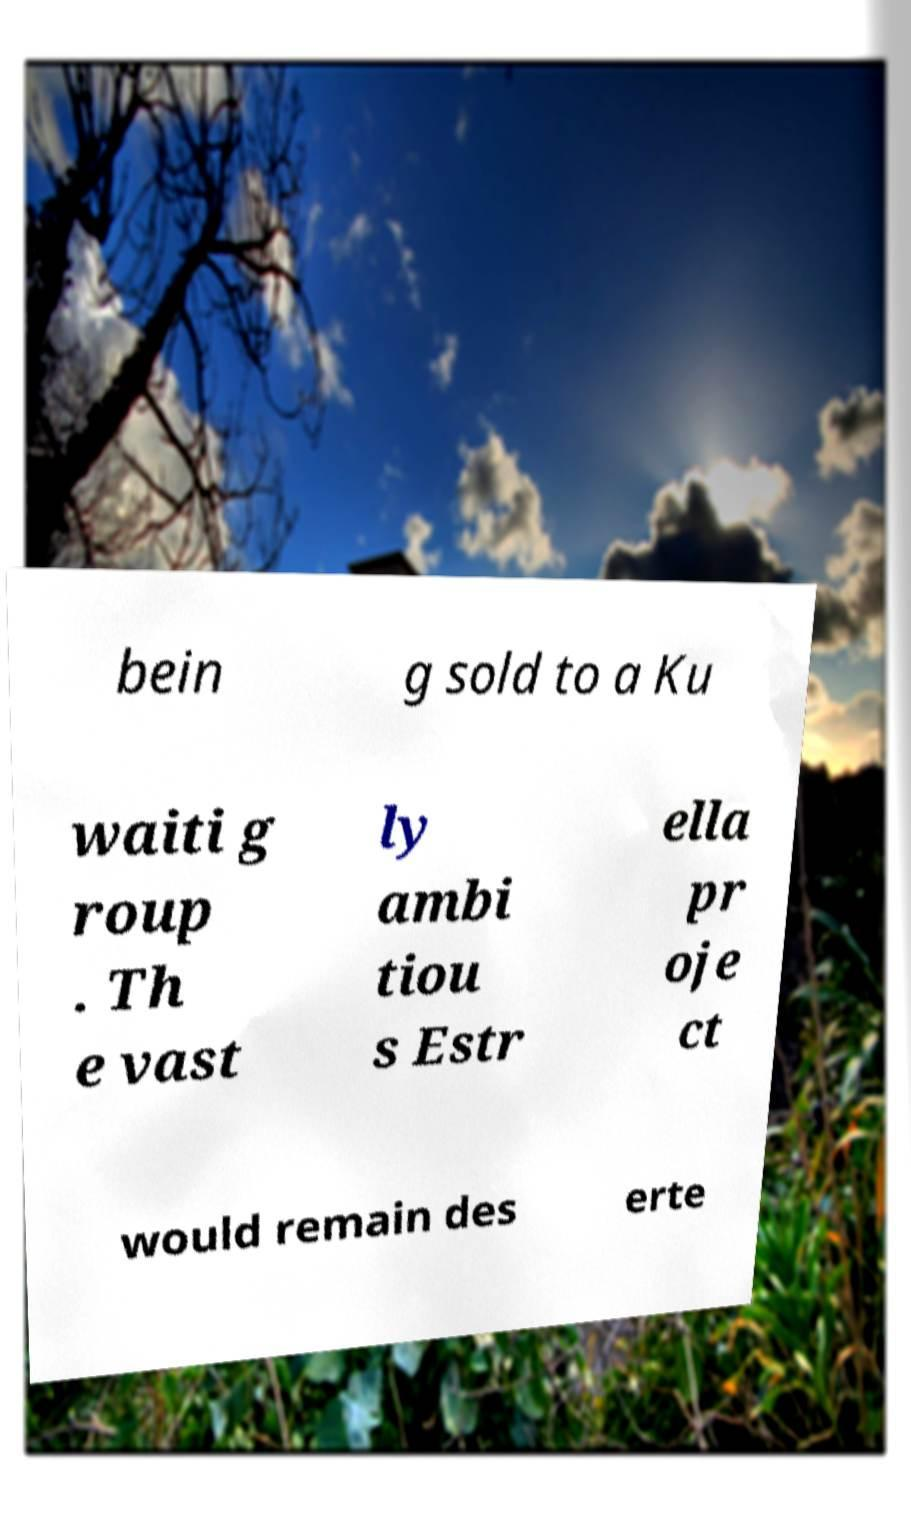Can you read and provide the text displayed in the image?This photo seems to have some interesting text. Can you extract and type it out for me? bein g sold to a Ku waiti g roup . Th e vast ly ambi tiou s Estr ella pr oje ct would remain des erte 